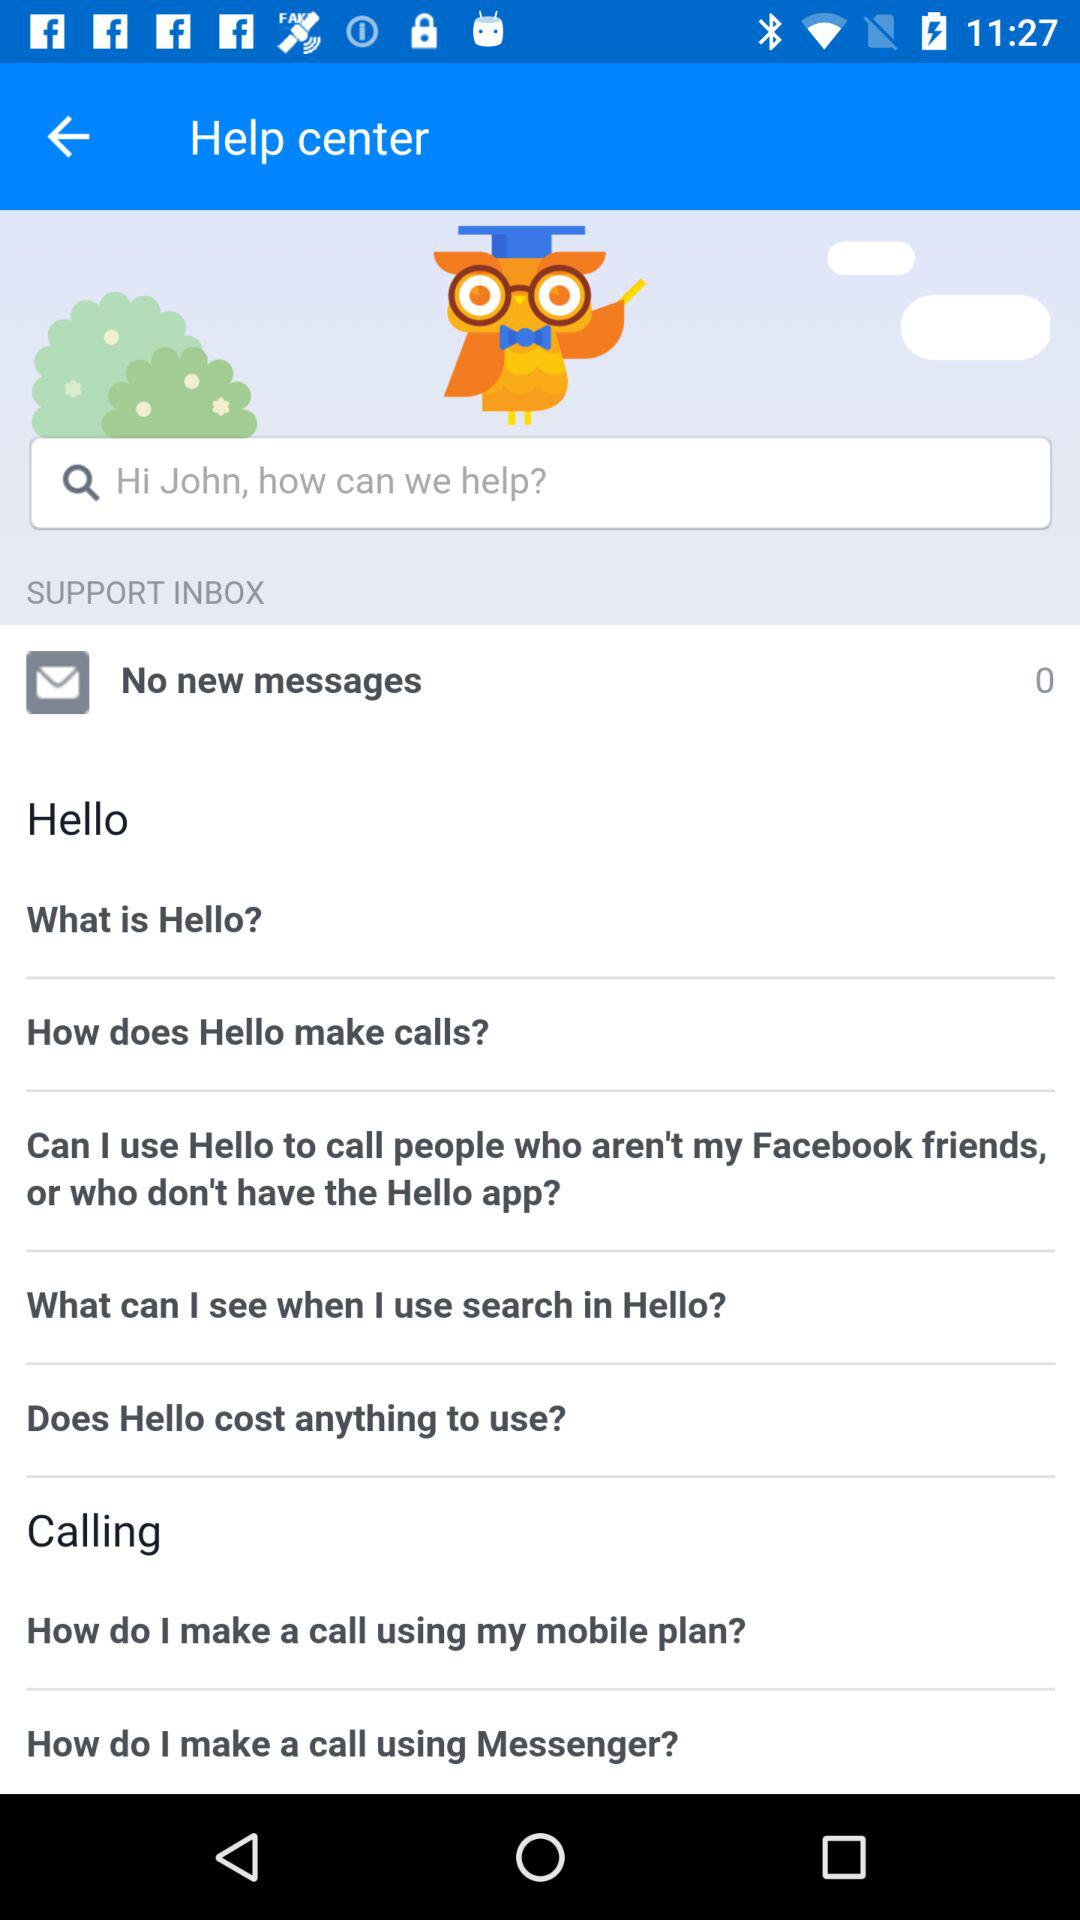What is the name of the user? The name of the user is John. 